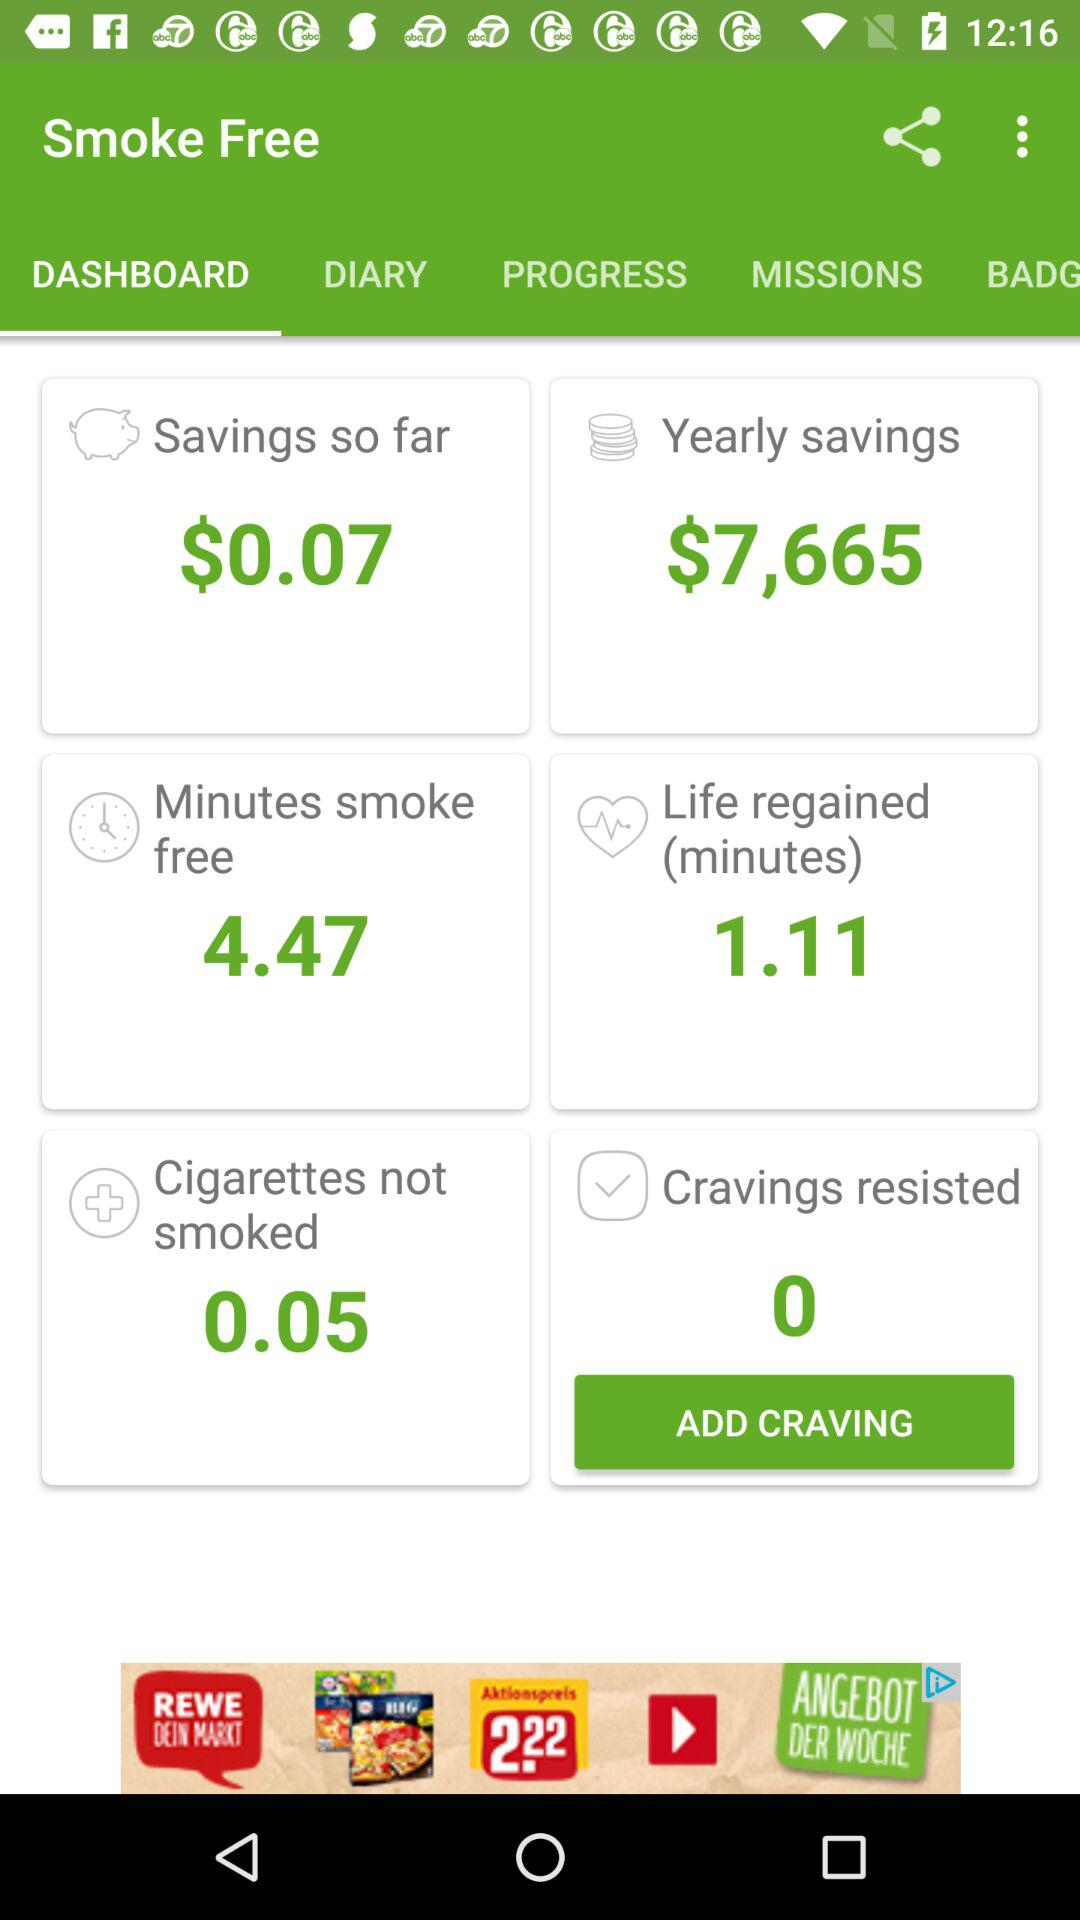Which option is selected? The selected option is "DASHBOARD". 